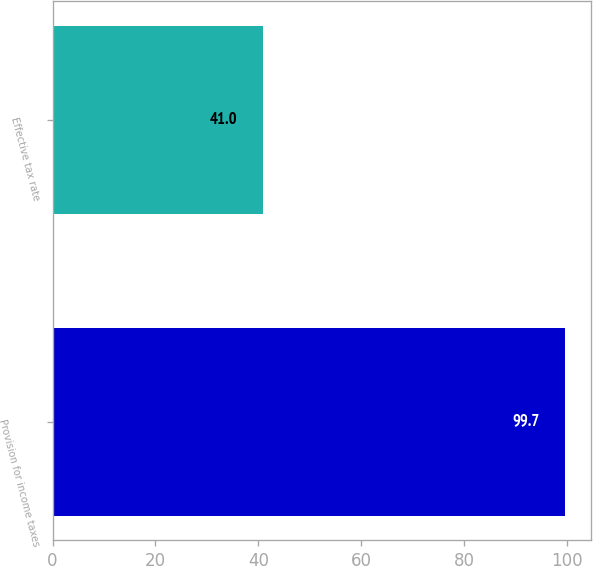<chart> <loc_0><loc_0><loc_500><loc_500><bar_chart><fcel>Provision for income taxes<fcel>Effective tax rate<nl><fcel>99.7<fcel>41<nl></chart> 